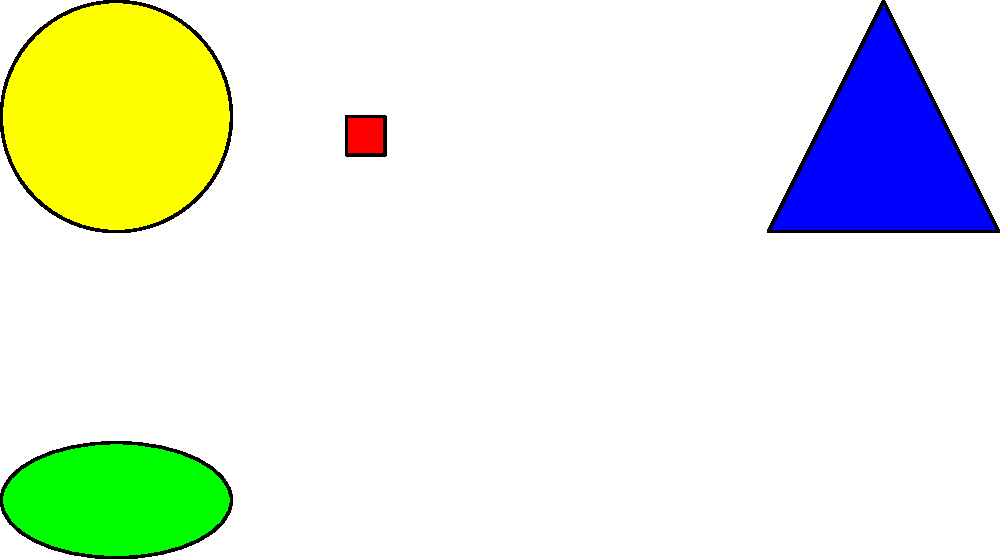Match the tactile symbols (A-F) with the corresponding emotions or social situations:

1. Excitement
2. Anger
3. Sadness
4. Calmness
5. Happiness
6. Confusion

Which symbol would you associate with "Happiness"? To answer this question, we need to consider the characteristics of each shape and how they might relate to different emotions or social situations. Let's analyze each shape:

1. Shape A (Circle): Smooth, continuous, and balanced. Often associated with completeness and harmony.
2. Shape B (Square): Rigid, stable, and structured. Can represent order or confinement.
3. Shape C (Triangle): Sharp, pointed, and dynamic. May symbolize direction or tension.
4. Shape D (Ellipse): Soft, elongated circle. Can represent calmness or gentleness.
5. Shape E (Hexagon): Balanced and structured, but softer than a square. Represents order with flexibility.
6. Shape F (Star): Radiating, energetic, and attention-grabbing. Often associated with positivity and excitement.

When considering "Happiness," we typically think of positive, uplifting emotions. The shape that best represents this would be the circle (Shape A). Circles are often associated with completeness, harmony, and positivity, which align well with the feeling of happiness.

The smooth, continuous nature of a circle can represent the warmth and wholeness often felt when experiencing happiness. Additionally, in many cultures, a circular shape (like a smiley face) is used to depict happiness or joy.
Answer: A 